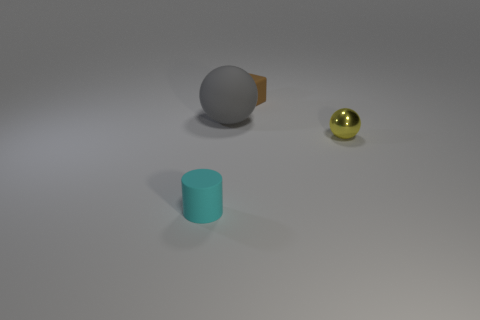Add 2 big cyan spheres. How many objects exist? 6 Add 1 yellow balls. How many yellow balls are left? 2 Add 4 gray matte spheres. How many gray matte spheres exist? 5 Subtract 0 red cylinders. How many objects are left? 4 Subtract all cylinders. How many objects are left? 3 Subtract all big green matte things. Subtract all shiny objects. How many objects are left? 3 